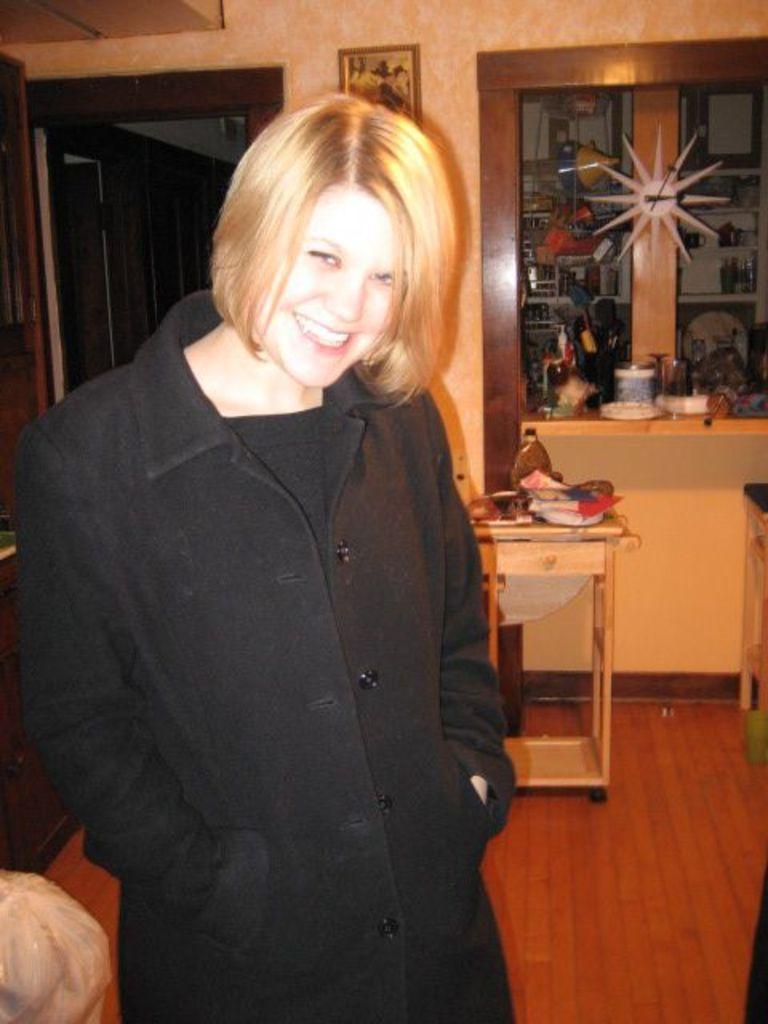Please provide a concise description of this image. In the image we can see a women back of her there is a door and a photo frame stick to the wall. 